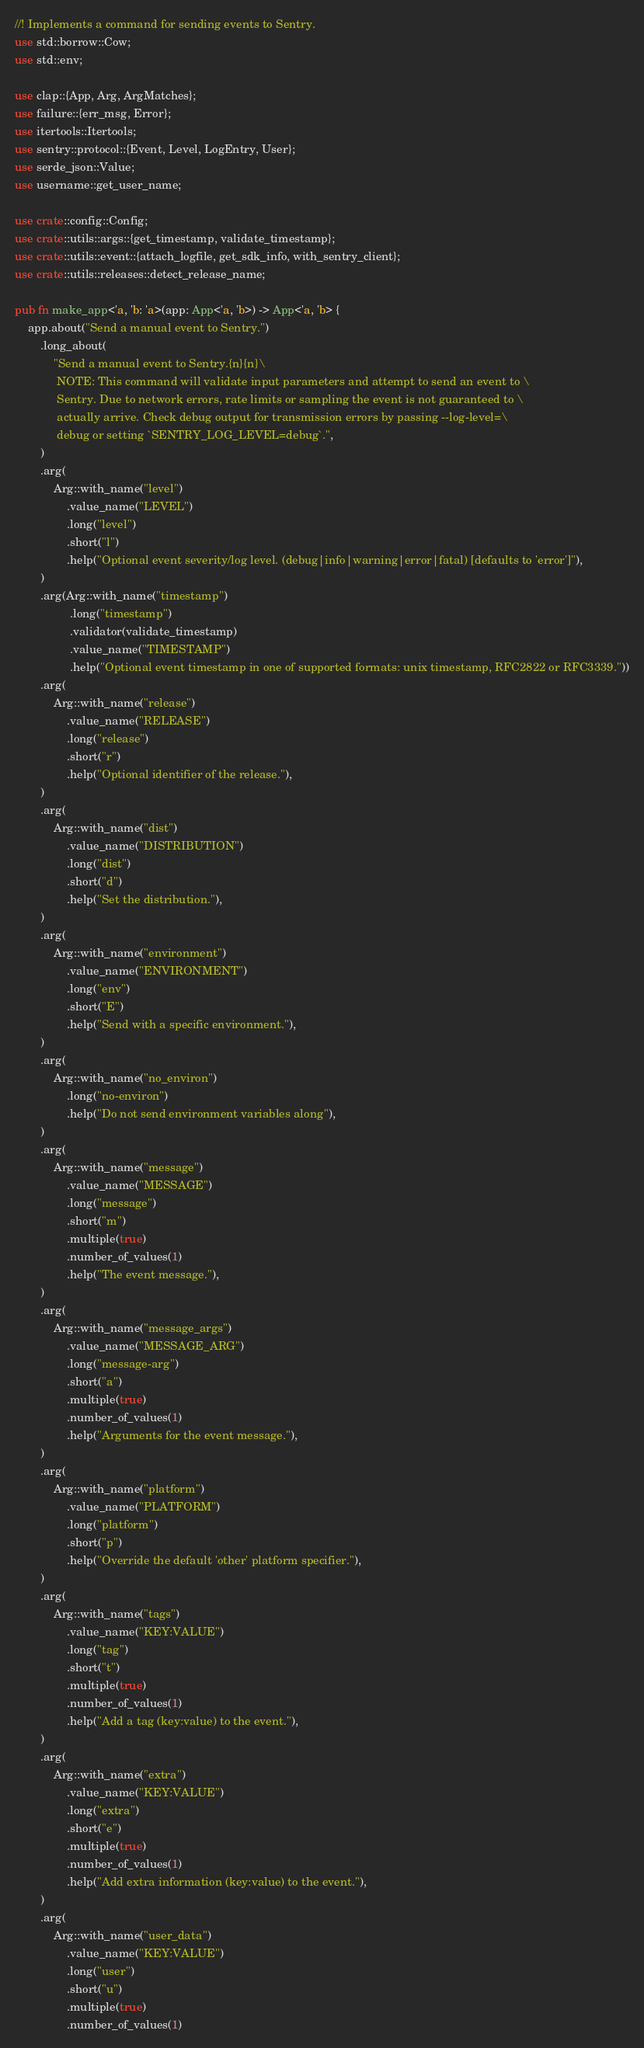Convert code to text. <code><loc_0><loc_0><loc_500><loc_500><_Rust_>//! Implements a command for sending events to Sentry.
use std::borrow::Cow;
use std::env;

use clap::{App, Arg, ArgMatches};
use failure::{err_msg, Error};
use itertools::Itertools;
use sentry::protocol::{Event, Level, LogEntry, User};
use serde_json::Value;
use username::get_user_name;

use crate::config::Config;
use crate::utils::args::{get_timestamp, validate_timestamp};
use crate::utils::event::{attach_logfile, get_sdk_info, with_sentry_client};
use crate::utils::releases::detect_release_name;

pub fn make_app<'a, 'b: 'a>(app: App<'a, 'b>) -> App<'a, 'b> {
    app.about("Send a manual event to Sentry.")
        .long_about(
            "Send a manual event to Sentry.{n}{n}\
             NOTE: This command will validate input parameters and attempt to send an event to \
             Sentry. Due to network errors, rate limits or sampling the event is not guaranteed to \
             actually arrive. Check debug output for transmission errors by passing --log-level=\
             debug or setting `SENTRY_LOG_LEVEL=debug`.",
        )
        .arg(
            Arg::with_name("level")
                .value_name("LEVEL")
                .long("level")
                .short("l")
                .help("Optional event severity/log level. (debug|info|warning|error|fatal) [defaults to 'error']"),
        )
        .arg(Arg::with_name("timestamp")
                 .long("timestamp")
                 .validator(validate_timestamp)
                 .value_name("TIMESTAMP")
                 .help("Optional event timestamp in one of supported formats: unix timestamp, RFC2822 or RFC3339."))
        .arg(
            Arg::with_name("release")
                .value_name("RELEASE")
                .long("release")
                .short("r")
                .help("Optional identifier of the release."),
        )
        .arg(
            Arg::with_name("dist")
                .value_name("DISTRIBUTION")
                .long("dist")
                .short("d")
                .help("Set the distribution."),
        )
        .arg(
            Arg::with_name("environment")
                .value_name("ENVIRONMENT")
                .long("env")
                .short("E")
                .help("Send with a specific environment."),
        )
        .arg(
            Arg::with_name("no_environ")
                .long("no-environ")
                .help("Do not send environment variables along"),
        )
        .arg(
            Arg::with_name("message")
                .value_name("MESSAGE")
                .long("message")
                .short("m")
                .multiple(true)
                .number_of_values(1)
                .help("The event message."),
        )
        .arg(
            Arg::with_name("message_args")
                .value_name("MESSAGE_ARG")
                .long("message-arg")
                .short("a")
                .multiple(true)
                .number_of_values(1)
                .help("Arguments for the event message."),
        )
        .arg(
            Arg::with_name("platform")
                .value_name("PLATFORM")
                .long("platform")
                .short("p")
                .help("Override the default 'other' platform specifier."),
        )
        .arg(
            Arg::with_name("tags")
                .value_name("KEY:VALUE")
                .long("tag")
                .short("t")
                .multiple(true)
                .number_of_values(1)
                .help("Add a tag (key:value) to the event."),
        )
        .arg(
            Arg::with_name("extra")
                .value_name("KEY:VALUE")
                .long("extra")
                .short("e")
                .multiple(true)
                .number_of_values(1)
                .help("Add extra information (key:value) to the event."),
        )
        .arg(
            Arg::with_name("user_data")
                .value_name("KEY:VALUE")
                .long("user")
                .short("u")
                .multiple(true)
                .number_of_values(1)</code> 